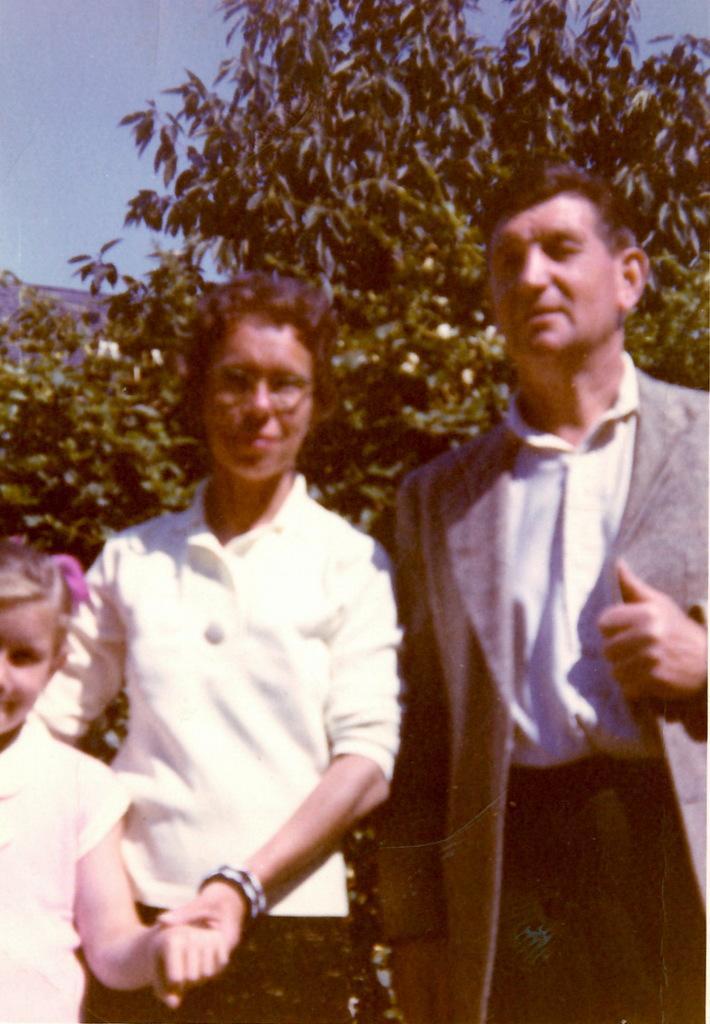How would you summarize this image in a sentence or two? The man on the right side who is wearing a white shirt and grey blazer is standing. Beside him, the woman in the white shirt is standing and she is holding the hands of a girl, who is wearing a white shirt. There are trees in the background. In the left top of the picture, we see the sky. 